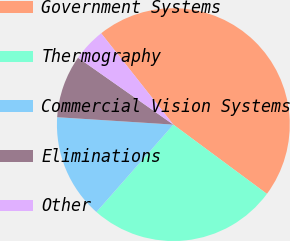Convert chart. <chart><loc_0><loc_0><loc_500><loc_500><pie_chart><fcel>Government Systems<fcel>Thermography<fcel>Commercial Vision Systems<fcel>Eliminations<fcel>Other<nl><fcel>45.79%<fcel>26.34%<fcel>14.53%<fcel>8.73%<fcel>4.61%<nl></chart> 